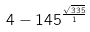Convert formula to latex. <formula><loc_0><loc_0><loc_500><loc_500>4 - 1 4 5 ^ { \frac { \sqrt { 3 3 5 } } { 1 } }</formula> 